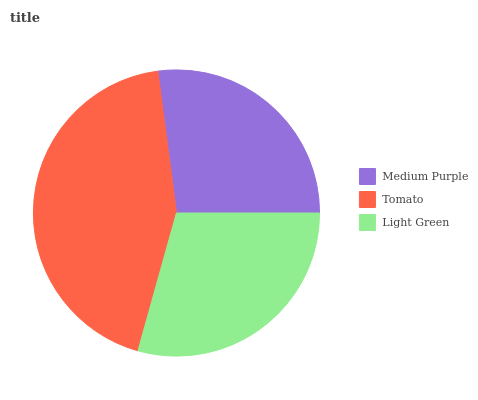Is Medium Purple the minimum?
Answer yes or no. Yes. Is Tomato the maximum?
Answer yes or no. Yes. Is Light Green the minimum?
Answer yes or no. No. Is Light Green the maximum?
Answer yes or no. No. Is Tomato greater than Light Green?
Answer yes or no. Yes. Is Light Green less than Tomato?
Answer yes or no. Yes. Is Light Green greater than Tomato?
Answer yes or no. No. Is Tomato less than Light Green?
Answer yes or no. No. Is Light Green the high median?
Answer yes or no. Yes. Is Light Green the low median?
Answer yes or no. Yes. Is Tomato the high median?
Answer yes or no. No. Is Tomato the low median?
Answer yes or no. No. 